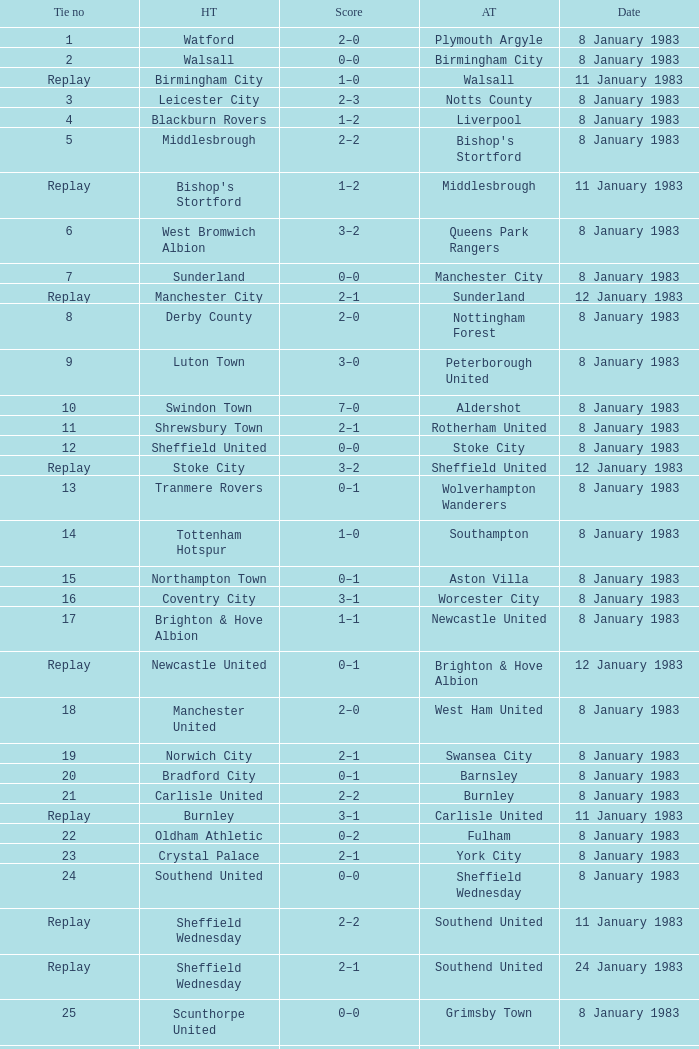What is the name of the away team for Tie #19? Swansea City. 